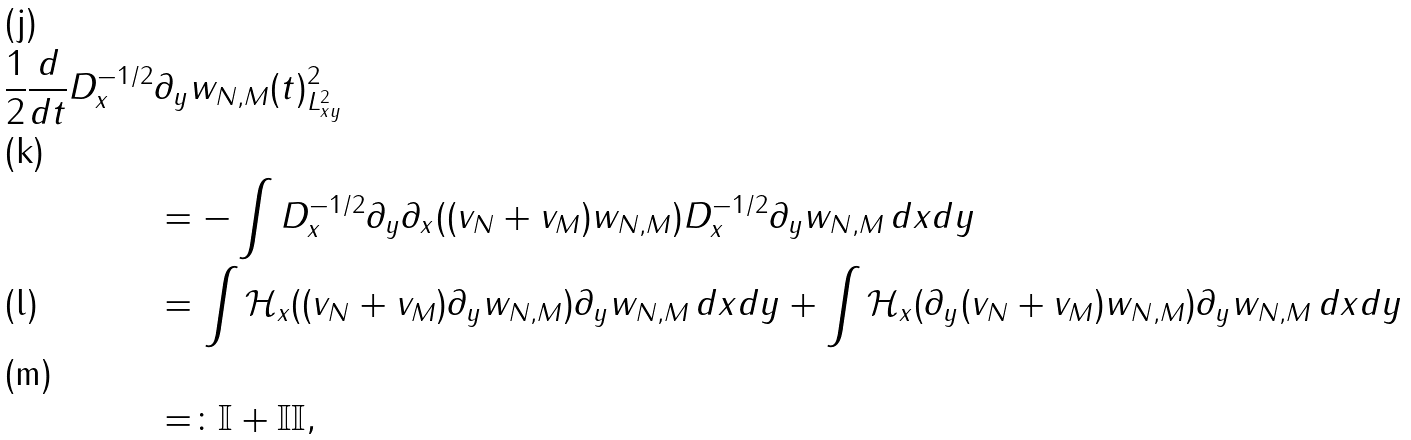Convert formula to latex. <formula><loc_0><loc_0><loc_500><loc_500>\frac { 1 } { 2 } \frac { d } { d t } \| D _ { x } ^ { - 1 / 2 } & \partial _ { y } w _ { N , M } ( t ) \| _ { L ^ { 2 } _ { x y } } ^ { 2 } \\ & = - \int D _ { x } ^ { - 1 / 2 } \partial _ { y } \partial _ { x } ( ( v _ { N } + v _ { M } ) w _ { N , M } ) D _ { x } ^ { - 1 / 2 } \partial _ { y } w _ { N , M } \, d x d y \\ & = \int \mathcal { H } _ { x } ( ( v _ { N } + v _ { M } ) \partial _ { y } w _ { N , M } ) \partial _ { y } w _ { N , M } \, d x d y + \int \mathcal { H } _ { x } ( \partial _ { y } ( v _ { N } + v _ { M } ) w _ { N , M } ) \partial _ { y } w _ { N , M } \, d x d y \\ & = \colon \mathbb { I } + \mathbb { I I } ,</formula> 